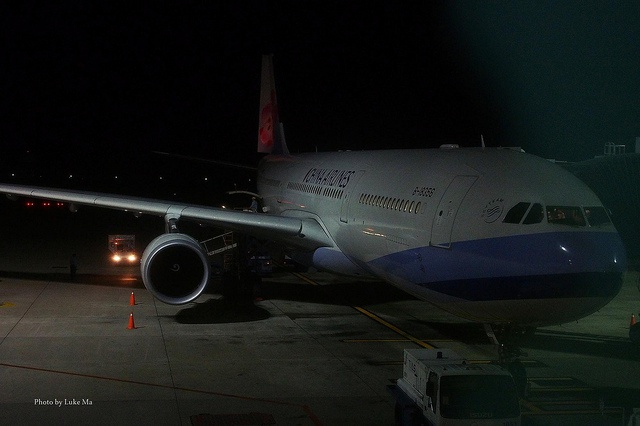Describe the objects in this image and their specific colors. I can see airplane in black, gray, and purple tones, truck in black tones, truck in black, maroon, and brown tones, and people in black tones in this image. 